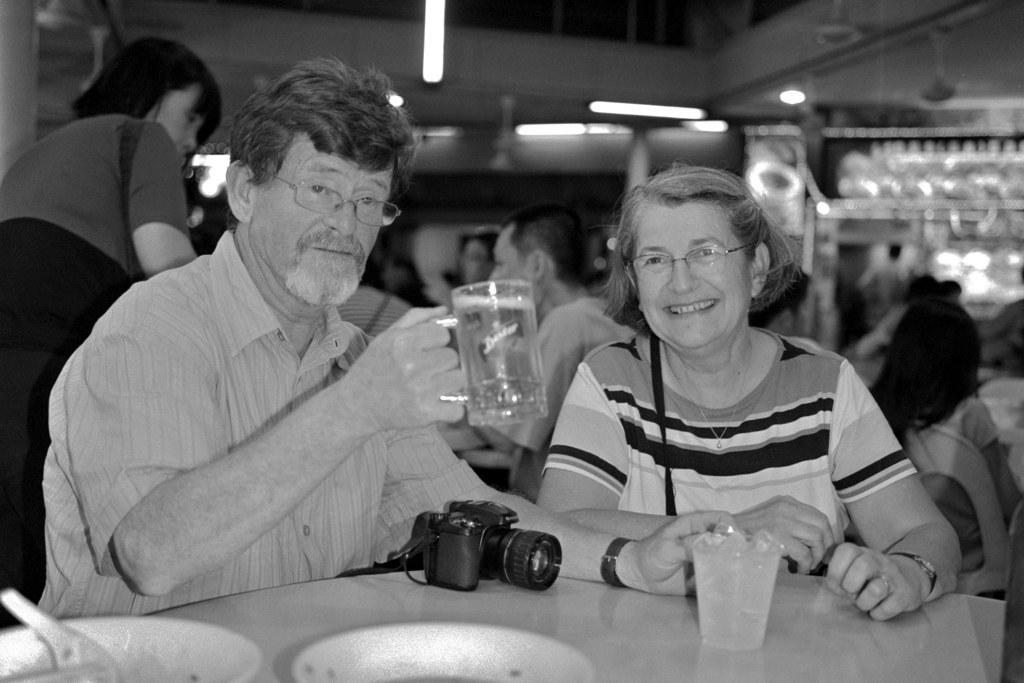How would you summarize this image in a sentence or two? In this, a man and a woman sitting side by side smiling. Man is holding a mug of beer. He wears a short and he has a goatee. He wears spectacles. He has a camera in front of him on the table. Woman wears T shirt. She too wears spectacles. She has short hair and she smiles showing her teeth. There are people behind them and the lights at the top. 